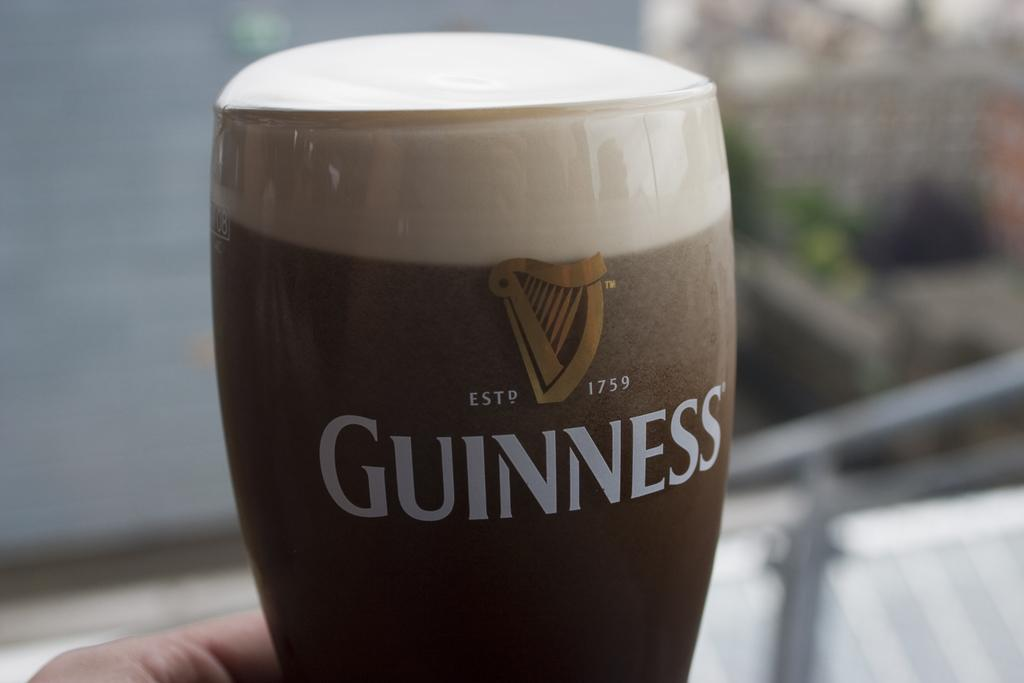<image>
Describe the image concisely. A pint of Guinness has a picture of a harp over the word. 